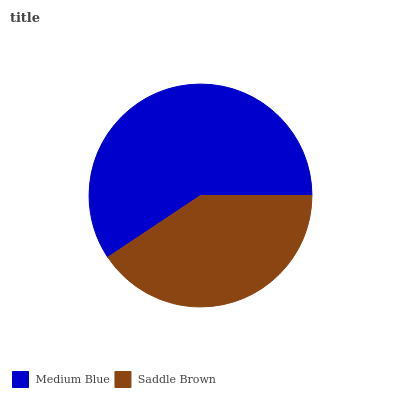Is Saddle Brown the minimum?
Answer yes or no. Yes. Is Medium Blue the maximum?
Answer yes or no. Yes. Is Saddle Brown the maximum?
Answer yes or no. No. Is Medium Blue greater than Saddle Brown?
Answer yes or no. Yes. Is Saddle Brown less than Medium Blue?
Answer yes or no. Yes. Is Saddle Brown greater than Medium Blue?
Answer yes or no. No. Is Medium Blue less than Saddle Brown?
Answer yes or no. No. Is Medium Blue the high median?
Answer yes or no. Yes. Is Saddle Brown the low median?
Answer yes or no. Yes. Is Saddle Brown the high median?
Answer yes or no. No. Is Medium Blue the low median?
Answer yes or no. No. 